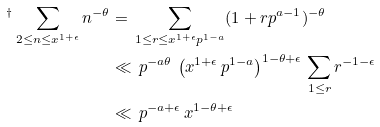<formula> <loc_0><loc_0><loc_500><loc_500>{ ^ { \dagger } } \sum _ { 2 \leq n \leq x ^ { 1 + \epsilon } } n ^ { - \theta } & = \, \sum _ { 1 \leq r \leq x ^ { 1 + \epsilon } p ^ { 1 - a } } ( 1 + r p ^ { a - 1 } ) ^ { - \theta } \\ & \ll \, p ^ { - a \theta } \, \left ( x ^ { 1 + \epsilon } \, p ^ { 1 - a } \right ) ^ { 1 - \theta + \epsilon } \, \sum _ { 1 \leq r } r ^ { - 1 - \epsilon } \\ & \ll \, p ^ { - a + \epsilon } \, x ^ { 1 - \theta + \epsilon }</formula> 